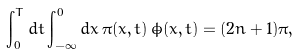<formula> <loc_0><loc_0><loc_500><loc_500>\int _ { 0 } ^ { T } d t \int _ { - \infty } ^ { 0 } d x \, \pi ( x , t ) \, \dot { \phi } ( x , t ) = ( 2 n + 1 ) \pi ,</formula> 